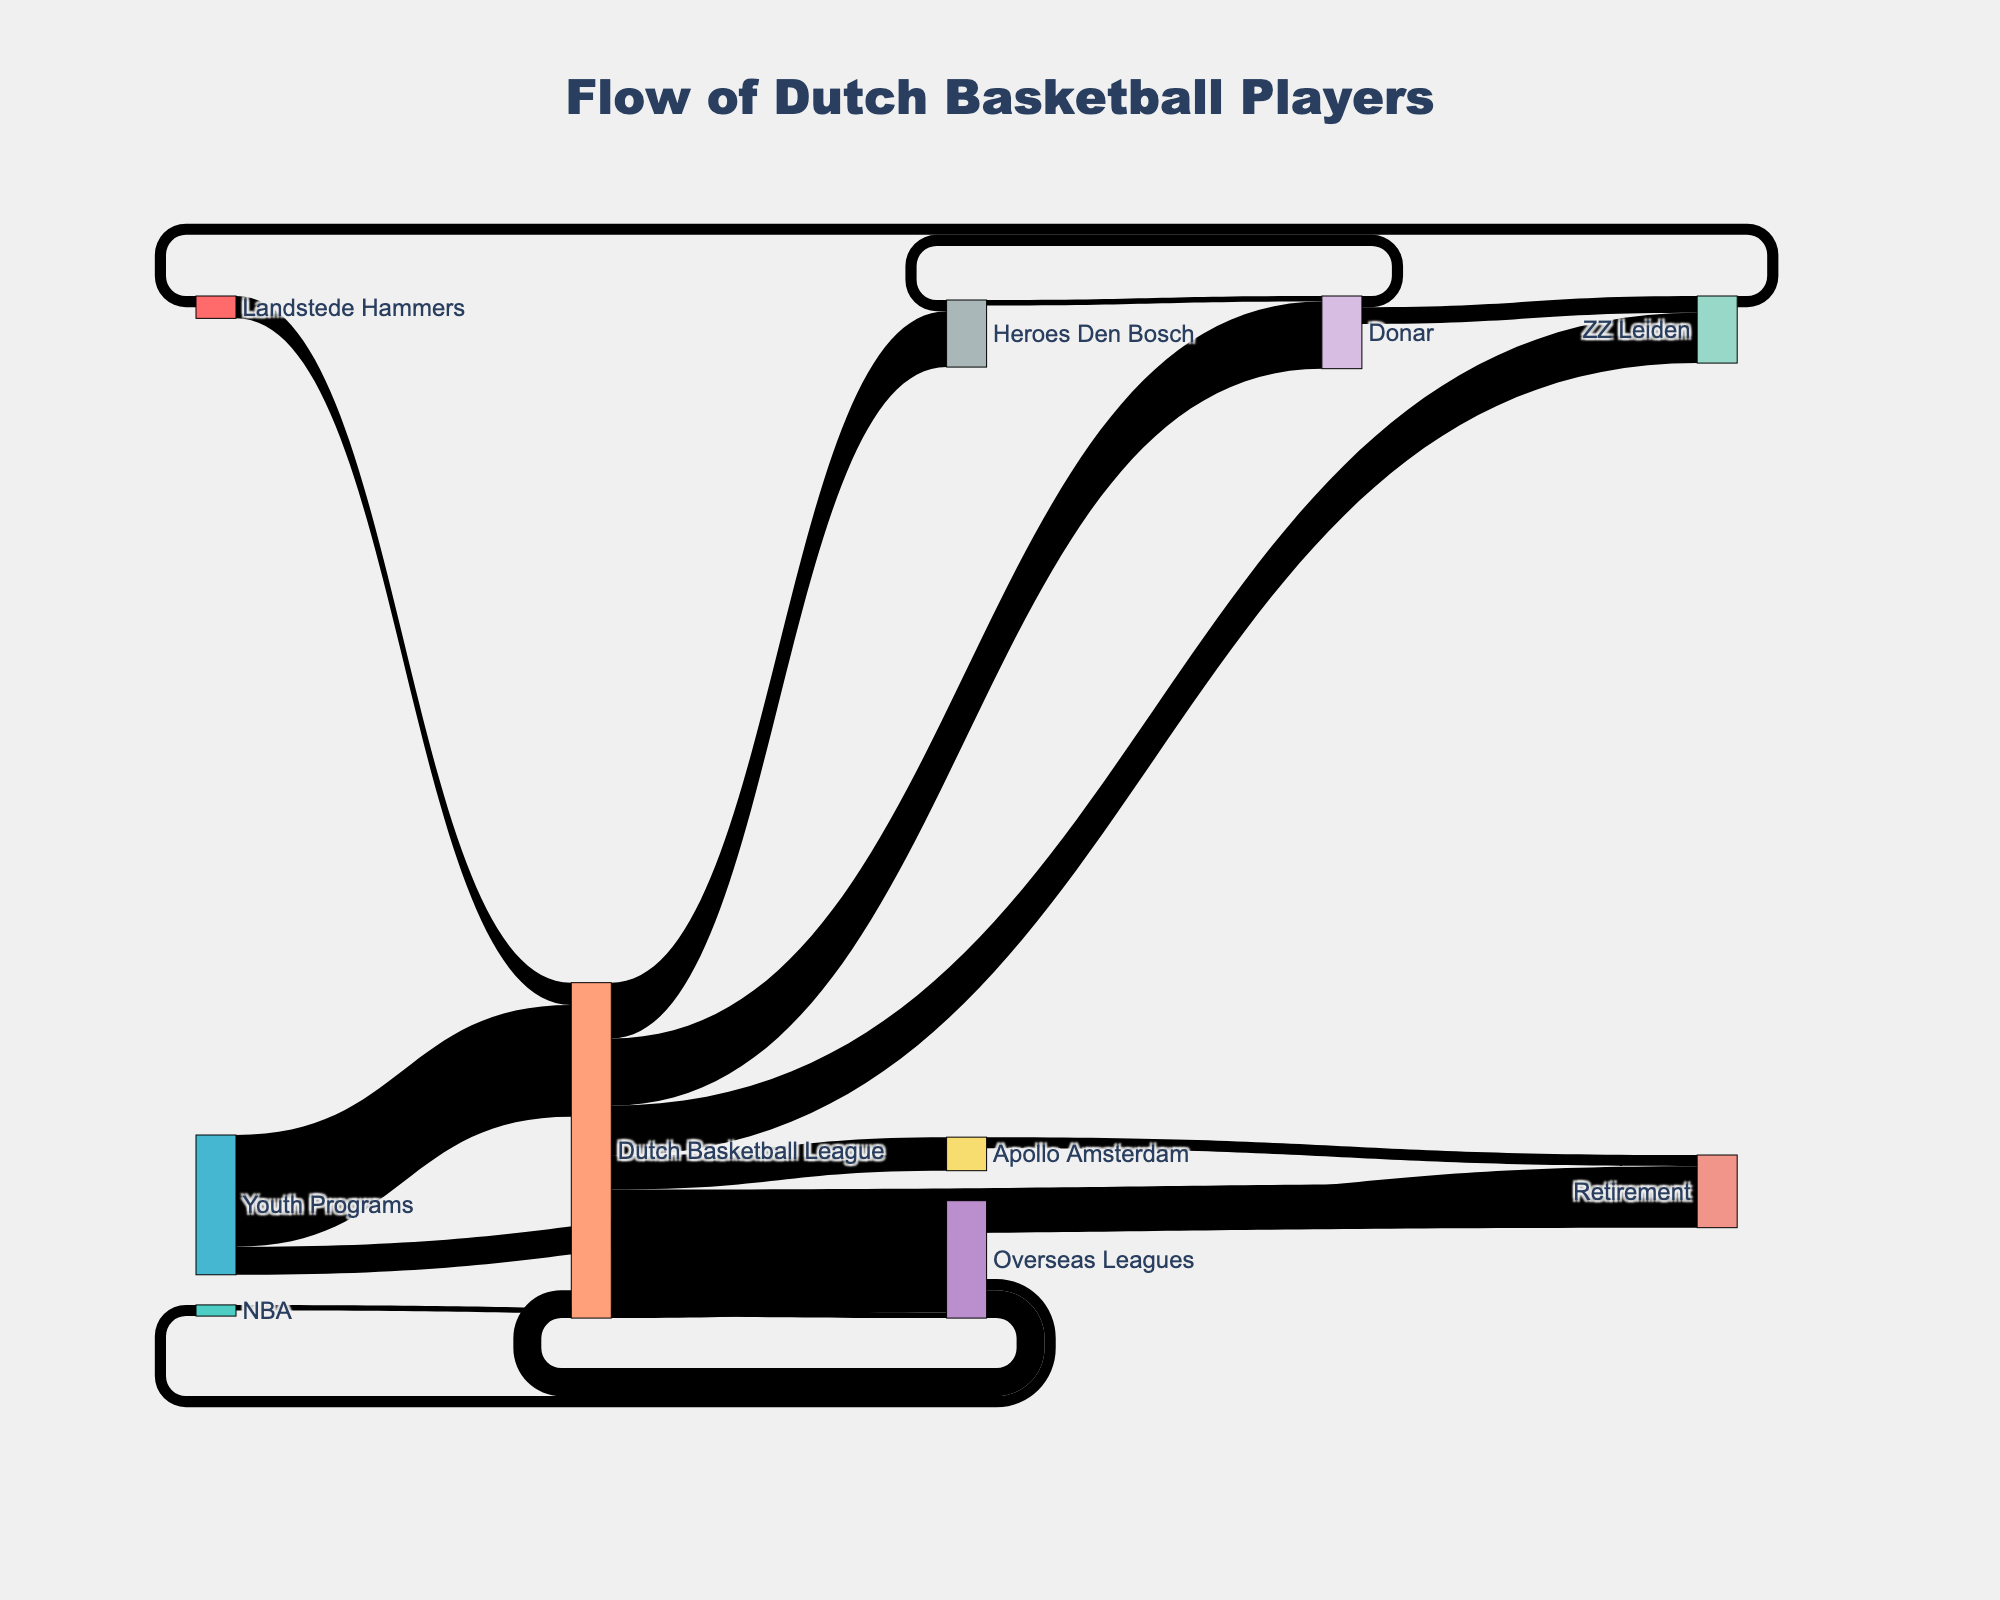what is the title of the diagram? The title is usually located at the top of the chart and gives a brief description of what the data represents. In this case, it is "Flow of Dutch Basketball Players," which is evident from the title text in the diagram.
Answer: Flow of Dutch Basketball Players How many players transition from the Dutch Basketball League to Overseas Leagues? Find the Dutch Basketball League node and look at the link that connects it to Overseas Leagues. The link value indicates the number of players, which is 15.
Answer: 15 What is the most common next step for players coming from Youth Programs? Identify the node for Youth Programs and observe all the outgoing links. The link with the highest value shows the most common next step. The link to the Dutch Basketball League has the highest value, which is 20.
Answer: Dutch Basketball League Which league has the fewest players transitioning to Retirement? Observe all nodes with outgoing links to the Retirement node and compare their values. The Apollo Amsterdam node has the fewest players transitioning to Retirement with a value of 2.
Answer: Apollo Amsterdam What is the total number of players who leave the Dutch Basketball League? Sum the values of all outgoing links from the Dutch Basketball League node: Overseas Leagues (15), Retirement (8), Donar (12), Heroes Den Bosch (10), ZZ Leiden (9), and Apollo Amsterdam (6). This results in a total of 15 + 8 + 12 + 10 + 9 + 6 = 60.
Answer: 60 How many players moved between Donar and Heroes Den Bosch? Examine the links between Donar and Heroes Den Bosch in both directions. The link from Donar to Heroes Den Bosch has a value of 2, and the link from Heroes Den Bosch to Donar has a value of 1. The total number of players moving between these teams is 2 + 1 = 3.
Answer: 3 What percentage of youth program players transition directly into the Dutch Basketball League? Calculate the ratio of players moving from Youth Programs to the Dutch Basketball League to the total number of Youth Program players moving anywhere. This is (20/(20+5))*100 = 80%.
Answer: 80% How many players return from Overseas Leagues to the Dutch Basketball League? Find the link from Overseas Leagues to Dutch Basketball League and observe its value, which is 5.
Answer: 5 Which team received players through the highest number of transitions? Check the nodes (Donar, Heroes Den Bosch, and ZZ Leiden), and sum their incoming values: Donar (12 from DBL + 1 from Heroes = 13), Heroes Den Bosch (10 from DBL + 2 from Donar = 12), and ZZ Leiden (9 from DBL + 3 from Donar = 12). Donar received the highest with 13 players.
Answer: Donar 